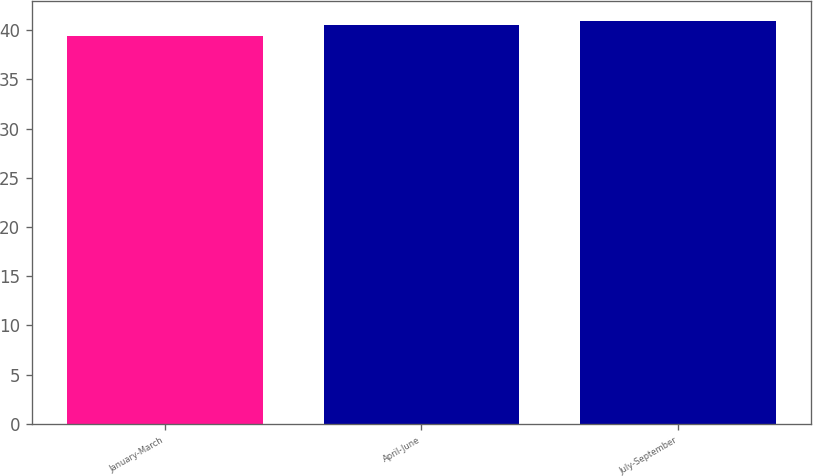Convert chart. <chart><loc_0><loc_0><loc_500><loc_500><bar_chart><fcel>January-March<fcel>April-June<fcel>July-September<nl><fcel>39.38<fcel>40.48<fcel>40.95<nl></chart> 